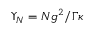<formula> <loc_0><loc_0><loc_500><loc_500>\Upsilon _ { N } = N g ^ { 2 } / \Gamma \kappa</formula> 